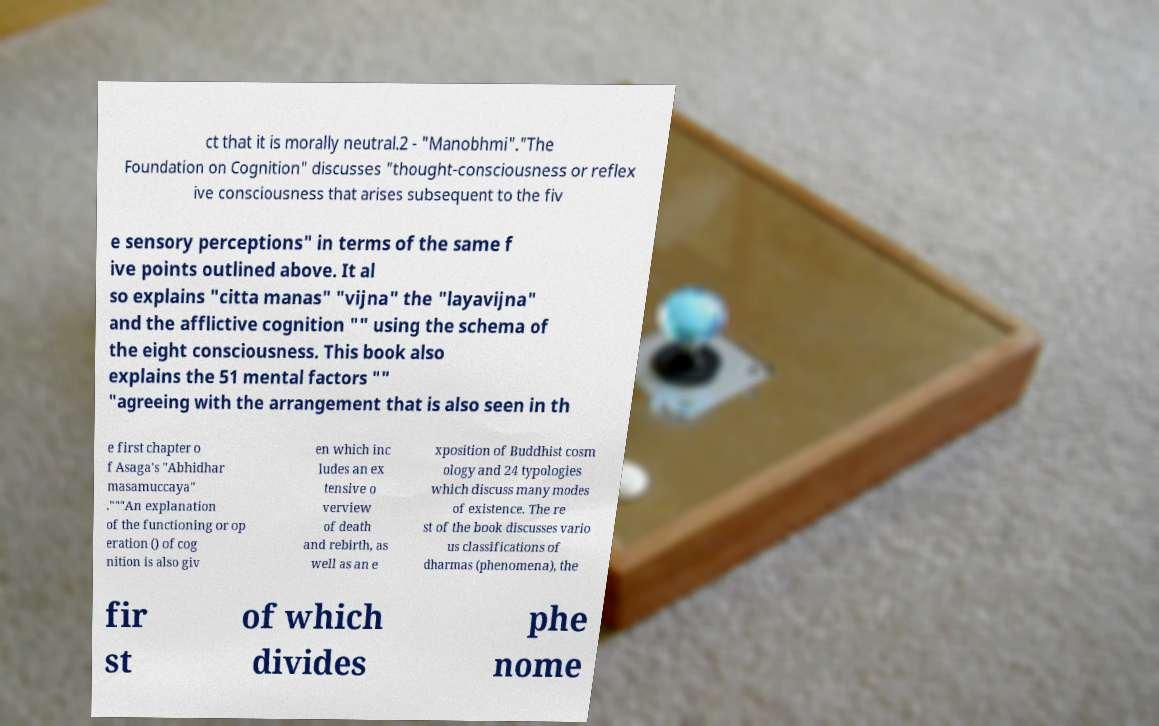Please identify and transcribe the text found in this image. ct that it is morally neutral.2 - "Manobhmi"."The Foundation on Cognition" discusses "thought-consciousness or reflex ive consciousness that arises subsequent to the fiv e sensory perceptions" in terms of the same f ive points outlined above. It al so explains "citta manas" "vijna" the "layavijna" and the afflictive cognition "" using the schema of the eight consciousness. This book also explains the 51 mental factors "" "agreeing with the arrangement that is also seen in th e first chapter o f Asaga's "Abhidhar masamuccaya" ."""An explanation of the functioning or op eration () of cog nition is also giv en which inc ludes an ex tensive o verview of death and rebirth, as well as an e xposition of Buddhist cosm ology and 24 typologies which discuss many modes of existence. The re st of the book discusses vario us classifications of dharmas (phenomena), the fir st of which divides phe nome 